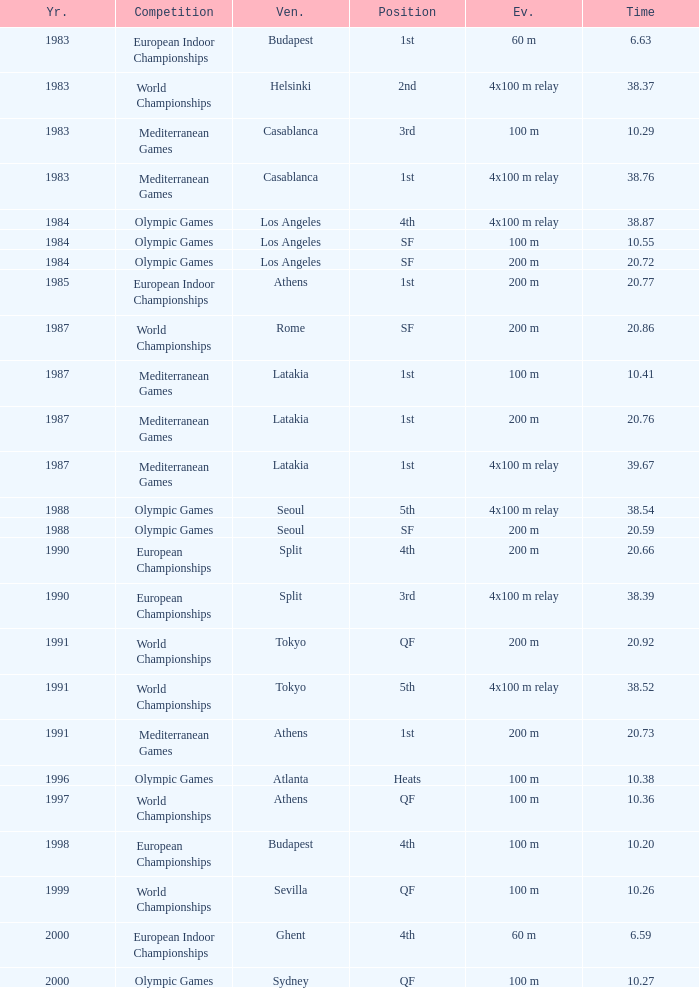What Position has a Time of 20.66? 4th. 